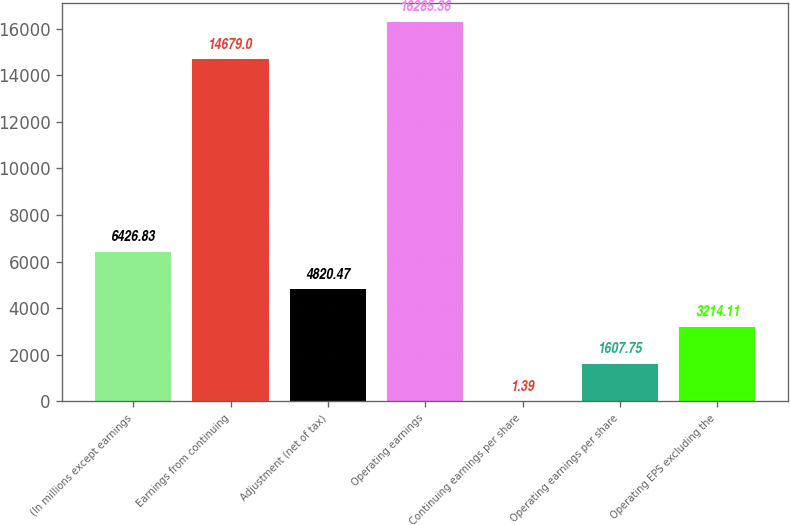<chart> <loc_0><loc_0><loc_500><loc_500><bar_chart><fcel>(In millions except earnings<fcel>Earnings from continuing<fcel>Adjustment (net of tax)<fcel>Operating earnings<fcel>Continuing earnings per share<fcel>Operating earnings per share<fcel>Operating EPS excluding the<nl><fcel>6426.83<fcel>14679<fcel>4820.47<fcel>16285.4<fcel>1.39<fcel>1607.75<fcel>3214.11<nl></chart> 